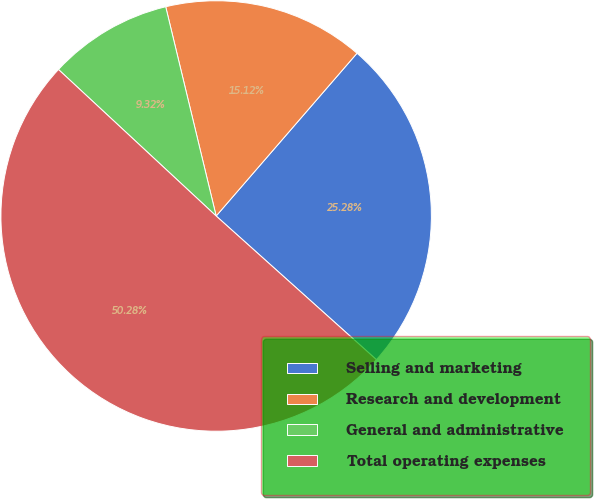<chart> <loc_0><loc_0><loc_500><loc_500><pie_chart><fcel>Selling and marketing<fcel>Research and development<fcel>General and administrative<fcel>Total operating expenses<nl><fcel>25.28%<fcel>15.12%<fcel>9.32%<fcel>50.28%<nl></chart> 